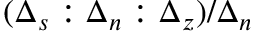Convert formula to latex. <formula><loc_0><loc_0><loc_500><loc_500>( \Delta _ { s } \colon \Delta _ { n } \colon \Delta _ { z } ) / \Delta _ { n }</formula> 